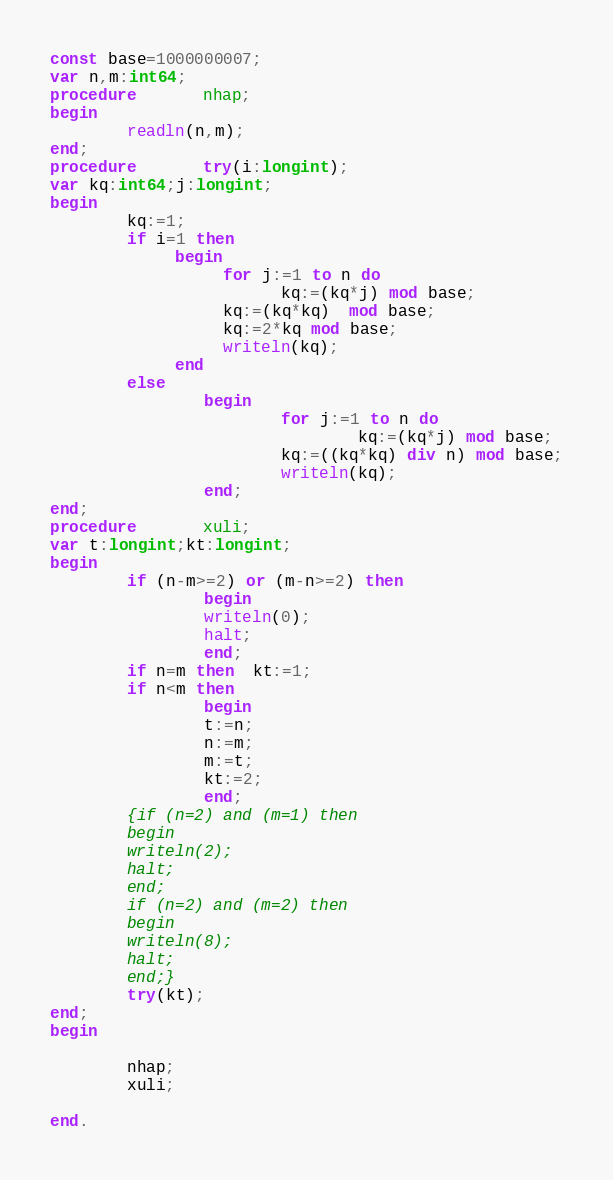Convert code to text. <code><loc_0><loc_0><loc_500><loc_500><_Pascal_>const base=1000000007;
var n,m:int64;
procedure       nhap;
begin
        readln(n,m);
end;
procedure       try(i:longint);
var kq:int64;j:longint;
begin
        kq:=1;
        if i=1 then
             begin
                  for j:=1 to n do
                        kq:=(kq*j) mod base;
                  kq:=(kq*kq)  mod base;
                  kq:=2*kq mod base;
                  writeln(kq);
             end
        else
                begin
                        for j:=1 to n do
                                kq:=(kq*j) mod base;
                        kq:=((kq*kq) div n) mod base;
                        writeln(kq);
                end;
end;
procedure       xuli;
var t:longint;kt:longint;
begin
        if (n-m>=2) or (m-n>=2) then
                begin
                writeln(0);
                halt;
                end;
        if n=m then  kt:=1;
        if n<m then
                begin
                t:=n;
                n:=m;
                m:=t;
                kt:=2;
                end;
        {if (n=2) and (m=1) then
        begin
        writeln(2);
        halt;
        end;
        if (n=2) and (m=2) then
        begin
        writeln(8);
        halt;
        end;}
        try(kt);
end;
begin
        
        nhap;
        xuli;
        
end.
</code> 